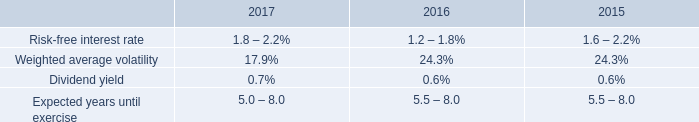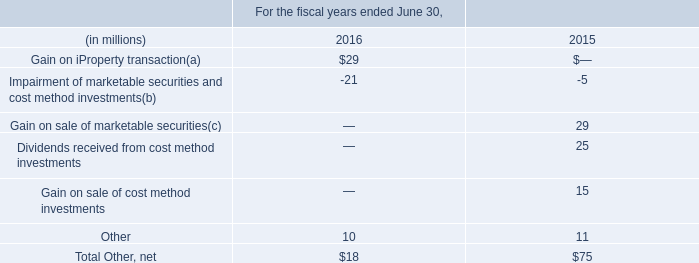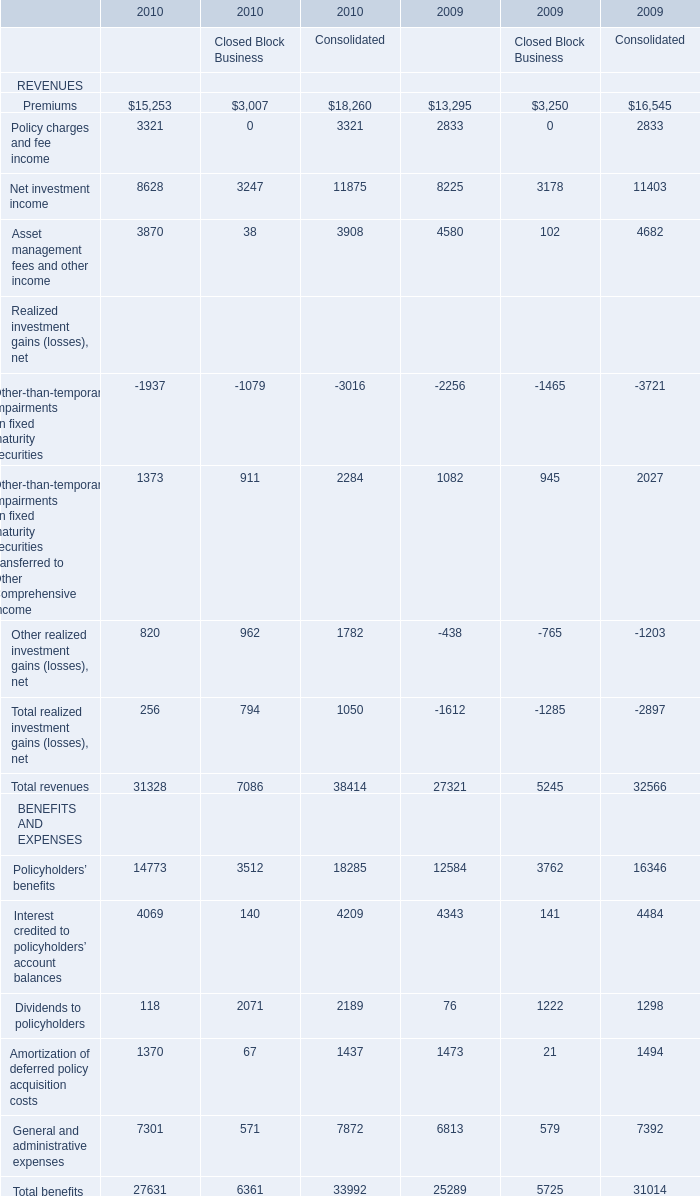What will Policyholders’ benefits for Consolidate reach in 2011 if it continues to grow at its current rate? 
Computations: ((((18285 - 16346) / 16346) + 1) * 18285)
Answer: 20454.00863. what on the net interest reduction of 13 million or 23% ( 23 % ) compared to 2015 what was the interest amount in 2016 in millions 
Computations: ((13 / 23%) + 13)
Answer: 69.52174. 